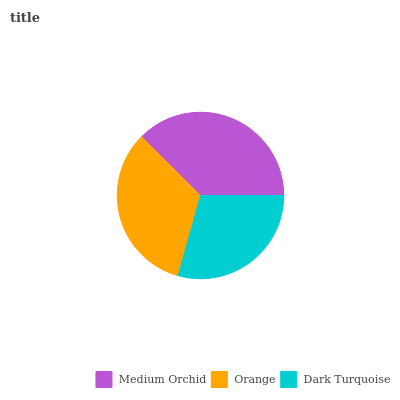Is Dark Turquoise the minimum?
Answer yes or no. Yes. Is Medium Orchid the maximum?
Answer yes or no. Yes. Is Orange the minimum?
Answer yes or no. No. Is Orange the maximum?
Answer yes or no. No. Is Medium Orchid greater than Orange?
Answer yes or no. Yes. Is Orange less than Medium Orchid?
Answer yes or no. Yes. Is Orange greater than Medium Orchid?
Answer yes or no. No. Is Medium Orchid less than Orange?
Answer yes or no. No. Is Orange the high median?
Answer yes or no. Yes. Is Orange the low median?
Answer yes or no. Yes. Is Medium Orchid the high median?
Answer yes or no. No. Is Dark Turquoise the low median?
Answer yes or no. No. 